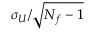Convert formula to latex. <formula><loc_0><loc_0><loc_500><loc_500>\sigma _ { U } / \sqrt { N _ { f } - 1 }</formula> 